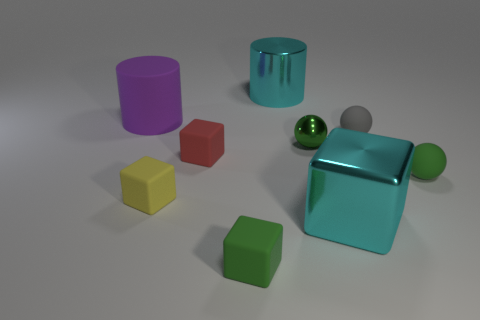Subtract all spheres. How many objects are left? 6 Add 3 big purple rubber cylinders. How many big purple rubber cylinders are left? 4 Add 9 large purple matte objects. How many large purple matte objects exist? 10 Subtract 0 yellow spheres. How many objects are left? 9 Subtract all shiny cubes. Subtract all small gray things. How many objects are left? 7 